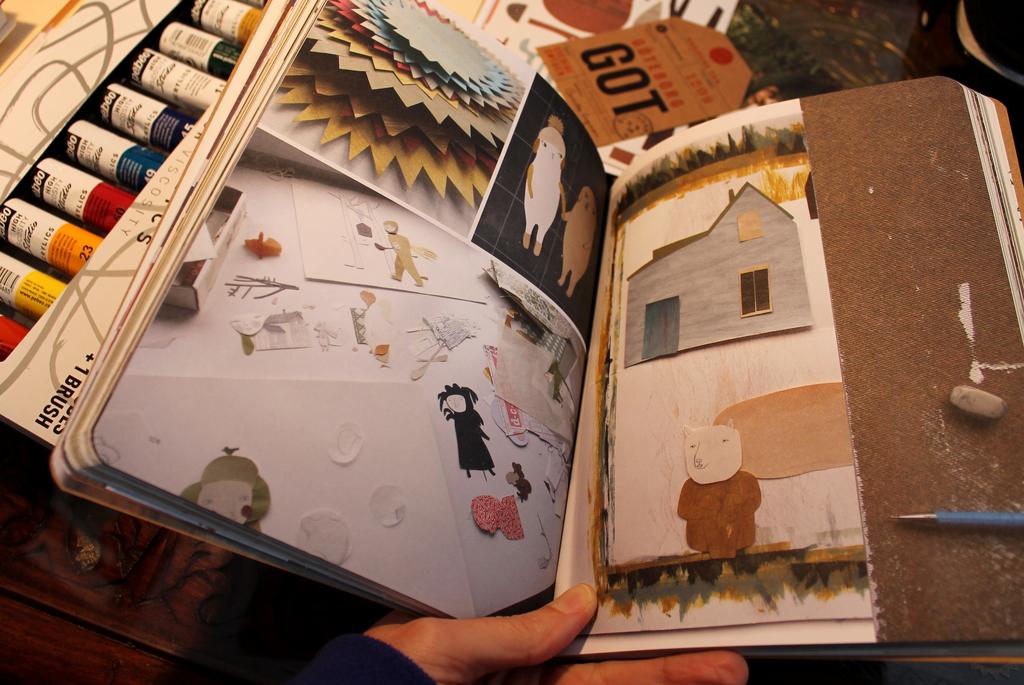What does the brown tag say?
Provide a succinct answer. Got. How many brushes come with the paint set?
Keep it short and to the point. 1. 